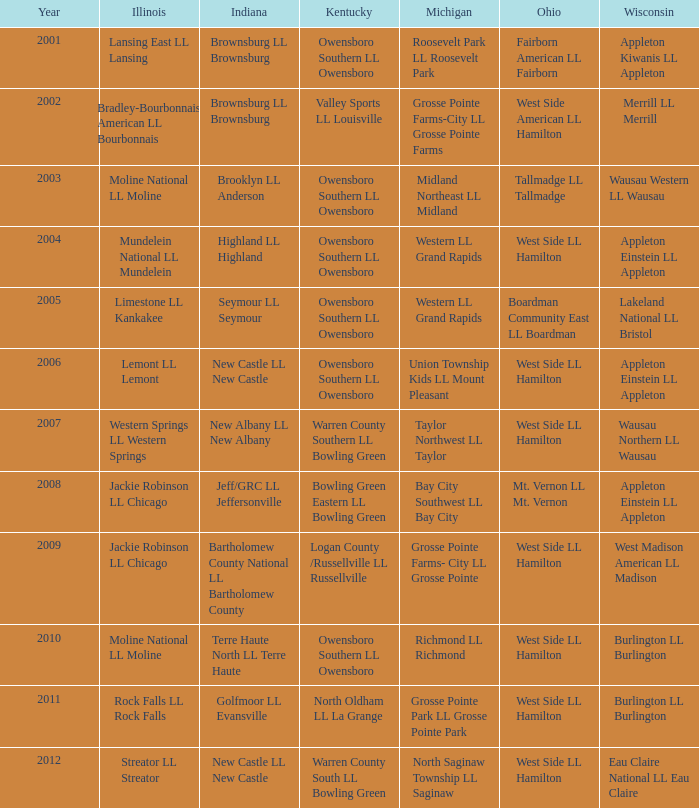What was the little league team from Michigan when the little league team from Indiana was Terre Haute North LL Terre Haute?  Richmond LL Richmond. Help me parse the entirety of this table. {'header': ['Year', 'Illinois', 'Indiana', 'Kentucky', 'Michigan', 'Ohio', 'Wisconsin'], 'rows': [['2001', 'Lansing East LL Lansing', 'Brownsburg LL Brownsburg', 'Owensboro Southern LL Owensboro', 'Roosevelt Park LL Roosevelt Park', 'Fairborn American LL Fairborn', 'Appleton Kiwanis LL Appleton'], ['2002', 'Bradley-Bourbonnais American LL Bourbonnais', 'Brownsburg LL Brownsburg', 'Valley Sports LL Louisville', 'Grosse Pointe Farms-City LL Grosse Pointe Farms', 'West Side American LL Hamilton', 'Merrill LL Merrill'], ['2003', 'Moline National LL Moline', 'Brooklyn LL Anderson', 'Owensboro Southern LL Owensboro', 'Midland Northeast LL Midland', 'Tallmadge LL Tallmadge', 'Wausau Western LL Wausau'], ['2004', 'Mundelein National LL Mundelein', 'Highland LL Highland', 'Owensboro Southern LL Owensboro', 'Western LL Grand Rapids', 'West Side LL Hamilton', 'Appleton Einstein LL Appleton'], ['2005', 'Limestone LL Kankakee', 'Seymour LL Seymour', 'Owensboro Southern LL Owensboro', 'Western LL Grand Rapids', 'Boardman Community East LL Boardman', 'Lakeland National LL Bristol'], ['2006', 'Lemont LL Lemont', 'New Castle LL New Castle', 'Owensboro Southern LL Owensboro', 'Union Township Kids LL Mount Pleasant', 'West Side LL Hamilton', 'Appleton Einstein LL Appleton'], ['2007', 'Western Springs LL Western Springs', 'New Albany LL New Albany', 'Warren County Southern LL Bowling Green', 'Taylor Northwest LL Taylor', 'West Side LL Hamilton', 'Wausau Northern LL Wausau'], ['2008', 'Jackie Robinson LL Chicago', 'Jeff/GRC LL Jeffersonville', 'Bowling Green Eastern LL Bowling Green', 'Bay City Southwest LL Bay City', 'Mt. Vernon LL Mt. Vernon', 'Appleton Einstein LL Appleton'], ['2009', 'Jackie Robinson LL Chicago', 'Bartholomew County National LL Bartholomew County', 'Logan County /Russellville LL Russellville', 'Grosse Pointe Farms- City LL Grosse Pointe', 'West Side LL Hamilton', 'West Madison American LL Madison'], ['2010', 'Moline National LL Moline', 'Terre Haute North LL Terre Haute', 'Owensboro Southern LL Owensboro', 'Richmond LL Richmond', 'West Side LL Hamilton', 'Burlington LL Burlington'], ['2011', 'Rock Falls LL Rock Falls', 'Golfmoor LL Evansville', 'North Oldham LL La Grange', 'Grosse Pointe Park LL Grosse Pointe Park', 'West Side LL Hamilton', 'Burlington LL Burlington'], ['2012', 'Streator LL Streator', 'New Castle LL New Castle', 'Warren County South LL Bowling Green', 'North Saginaw Township LL Saginaw', 'West Side LL Hamilton', 'Eau Claire National LL Eau Claire']]} 